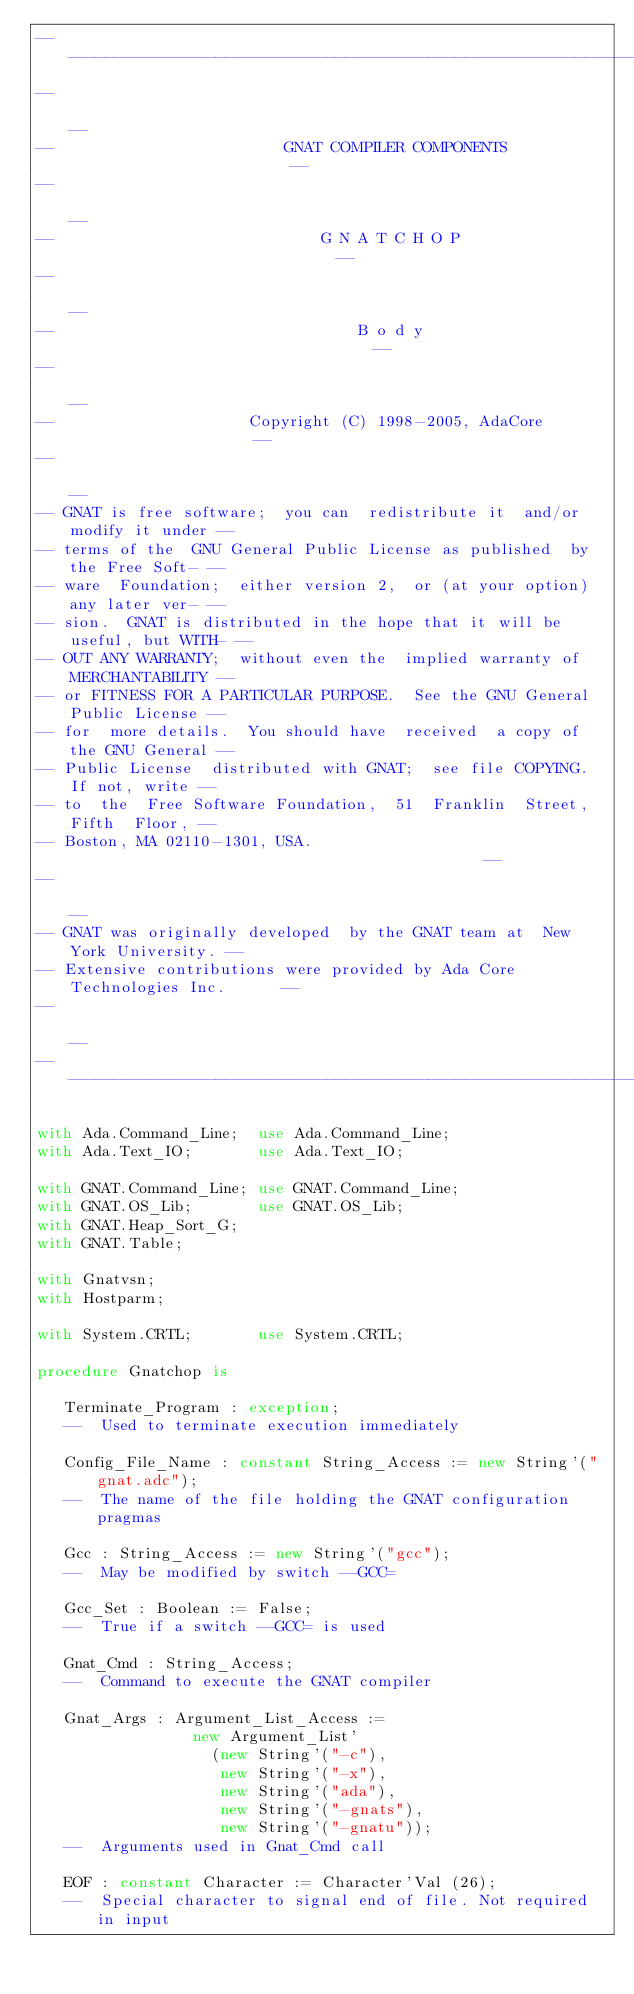<code> <loc_0><loc_0><loc_500><loc_500><_Ada_>------------------------------------------------------------------------------
--                                                                          --
--                         GNAT COMPILER COMPONENTS                         --
--                                                                          --
--                             G N A T C H O P                              --
--                                                                          --
--                                 B o d y                                  --
--                                                                          --
--                     Copyright (C) 1998-2005, AdaCore                     --
--                                                                          --
-- GNAT is free software;  you can  redistribute it  and/or modify it under --
-- terms of the  GNU General Public License as published  by the Free Soft- --
-- ware  Foundation;  either version 2,  or (at your option) any later ver- --
-- sion.  GNAT is distributed in the hope that it will be useful, but WITH- --
-- OUT ANY WARRANTY;  without even the  implied warranty of MERCHANTABILITY --
-- or FITNESS FOR A PARTICULAR PURPOSE.  See the GNU General Public License --
-- for  more details.  You should have  received  a copy of the GNU General --
-- Public License  distributed with GNAT;  see file COPYING.  If not, write --
-- to  the  Free Software Foundation,  51  Franklin  Street,  Fifth  Floor, --
-- Boston, MA 02110-1301, USA.                                              --
--                                                                          --
-- GNAT was originally developed  by the GNAT team at  New York University. --
-- Extensive contributions were provided by Ada Core Technologies Inc.      --
--                                                                          --
------------------------------------------------------------------------------

with Ada.Command_Line;  use Ada.Command_Line;
with Ada.Text_IO;       use Ada.Text_IO;

with GNAT.Command_Line; use GNAT.Command_Line;
with GNAT.OS_Lib;       use GNAT.OS_Lib;
with GNAT.Heap_Sort_G;
with GNAT.Table;

with Gnatvsn;
with Hostparm;

with System.CRTL;       use System.CRTL;

procedure Gnatchop is

   Terminate_Program : exception;
   --  Used to terminate execution immediately

   Config_File_Name : constant String_Access := new String'("gnat.adc");
   --  The name of the file holding the GNAT configuration pragmas

   Gcc : String_Access := new String'("gcc");
   --  May be modified by switch --GCC=

   Gcc_Set : Boolean := False;
   --  True if a switch --GCC= is used

   Gnat_Cmd : String_Access;
   --  Command to execute the GNAT compiler

   Gnat_Args : Argument_List_Access :=
                 new Argument_List'
                   (new String'("-c"),
                    new String'("-x"),
                    new String'("ada"),
                    new String'("-gnats"),
                    new String'("-gnatu"));
   --  Arguments used in Gnat_Cmd call

   EOF : constant Character := Character'Val (26);
   --  Special character to signal end of file. Not required in input</code> 